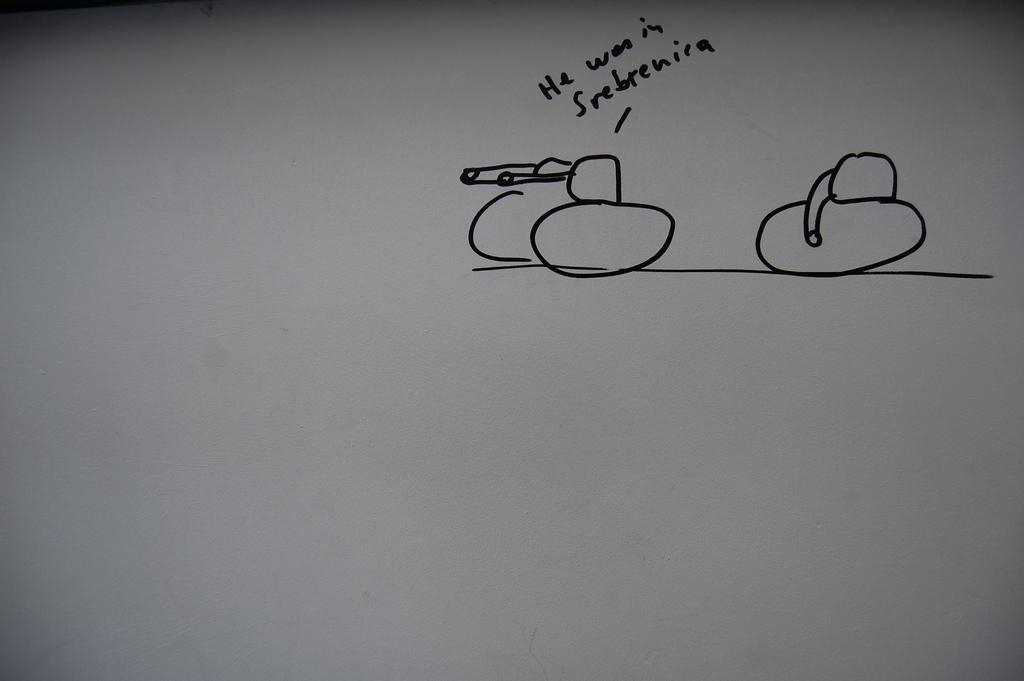Provide a one-sentence caption for the provided image. A cartoon of two tanks or two phallic symbols that says He was in Srebrenira. 